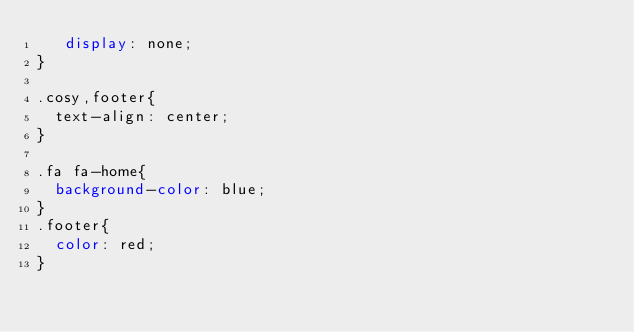<code> <loc_0><loc_0><loc_500><loc_500><_CSS_>   display: none;
}

.cosy,footer{
  text-align: center;
}

.fa fa-home{
  background-color: blue;
}
.footer{
  color: red;
}
</code> 